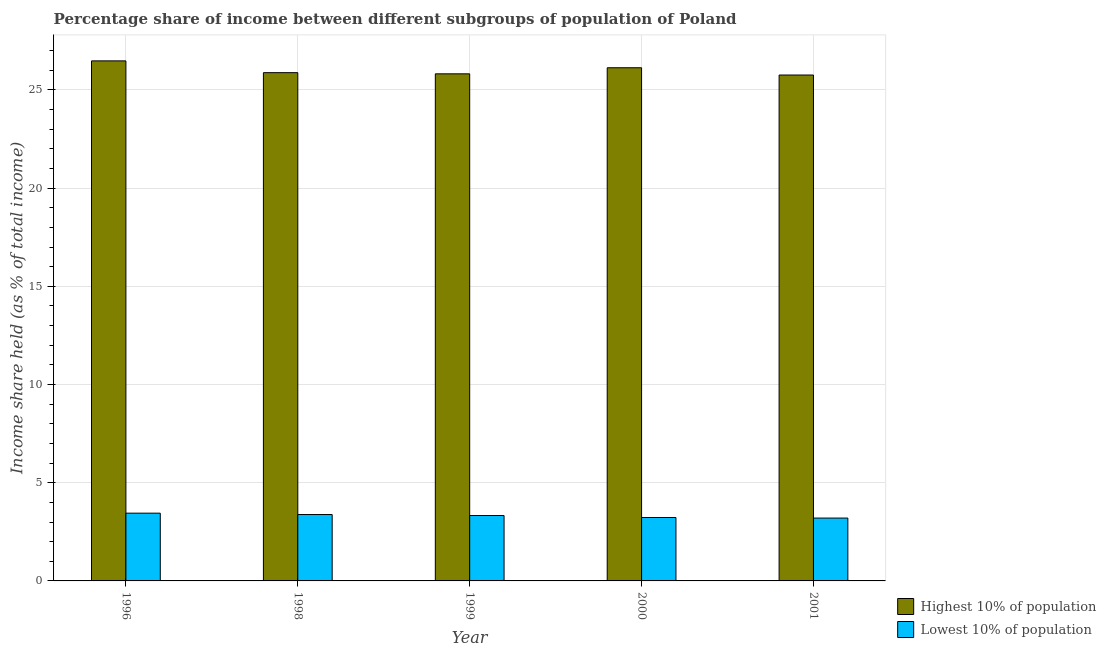How many different coloured bars are there?
Keep it short and to the point. 2. Are the number of bars per tick equal to the number of legend labels?
Your answer should be compact. Yes. How many bars are there on the 4th tick from the left?
Provide a succinct answer. 2. How many bars are there on the 1st tick from the right?
Your answer should be very brief. 2. What is the label of the 5th group of bars from the left?
Offer a very short reply. 2001. What is the income share held by lowest 10% of the population in 1999?
Make the answer very short. 3.33. Across all years, what is the maximum income share held by highest 10% of the population?
Keep it short and to the point. 26.48. In which year was the income share held by highest 10% of the population maximum?
Your answer should be compact. 1996. What is the total income share held by highest 10% of the population in the graph?
Keep it short and to the point. 130.07. What is the difference between the income share held by highest 10% of the population in 1998 and that in 1999?
Ensure brevity in your answer.  0.06. What is the difference between the income share held by highest 10% of the population in 1998 and the income share held by lowest 10% of the population in 1999?
Ensure brevity in your answer.  0.06. What is the average income share held by lowest 10% of the population per year?
Provide a short and direct response. 3.32. In the year 1996, what is the difference between the income share held by lowest 10% of the population and income share held by highest 10% of the population?
Your response must be concise. 0. In how many years, is the income share held by highest 10% of the population greater than 4 %?
Your response must be concise. 5. What is the ratio of the income share held by highest 10% of the population in 1996 to that in 2001?
Make the answer very short. 1.03. Is the difference between the income share held by lowest 10% of the population in 1996 and 2001 greater than the difference between the income share held by highest 10% of the population in 1996 and 2001?
Offer a terse response. No. What is the difference between the highest and the second highest income share held by lowest 10% of the population?
Offer a very short reply. 0.07. Is the sum of the income share held by highest 10% of the population in 1996 and 1999 greater than the maximum income share held by lowest 10% of the population across all years?
Your response must be concise. Yes. What does the 1st bar from the left in 2000 represents?
Your answer should be compact. Highest 10% of population. What does the 2nd bar from the right in 1998 represents?
Provide a succinct answer. Highest 10% of population. Are all the bars in the graph horizontal?
Ensure brevity in your answer.  No. How many years are there in the graph?
Ensure brevity in your answer.  5. What is the difference between two consecutive major ticks on the Y-axis?
Ensure brevity in your answer.  5. Are the values on the major ticks of Y-axis written in scientific E-notation?
Offer a very short reply. No. Where does the legend appear in the graph?
Give a very brief answer. Bottom right. What is the title of the graph?
Make the answer very short. Percentage share of income between different subgroups of population of Poland. Does "Taxes on exports" appear as one of the legend labels in the graph?
Give a very brief answer. No. What is the label or title of the X-axis?
Offer a very short reply. Year. What is the label or title of the Y-axis?
Your answer should be very brief. Income share held (as % of total income). What is the Income share held (as % of total income) in Highest 10% of population in 1996?
Your response must be concise. 26.48. What is the Income share held (as % of total income) of Lowest 10% of population in 1996?
Offer a very short reply. 3.45. What is the Income share held (as % of total income) of Highest 10% of population in 1998?
Offer a very short reply. 25.88. What is the Income share held (as % of total income) of Lowest 10% of population in 1998?
Your answer should be very brief. 3.38. What is the Income share held (as % of total income) of Highest 10% of population in 1999?
Offer a very short reply. 25.82. What is the Income share held (as % of total income) of Lowest 10% of population in 1999?
Your response must be concise. 3.33. What is the Income share held (as % of total income) in Highest 10% of population in 2000?
Make the answer very short. 26.13. What is the Income share held (as % of total income) in Lowest 10% of population in 2000?
Your answer should be compact. 3.23. What is the Income share held (as % of total income) of Highest 10% of population in 2001?
Offer a very short reply. 25.76. What is the Income share held (as % of total income) in Lowest 10% of population in 2001?
Provide a short and direct response. 3.2. Across all years, what is the maximum Income share held (as % of total income) in Highest 10% of population?
Keep it short and to the point. 26.48. Across all years, what is the maximum Income share held (as % of total income) in Lowest 10% of population?
Give a very brief answer. 3.45. Across all years, what is the minimum Income share held (as % of total income) in Highest 10% of population?
Provide a succinct answer. 25.76. Across all years, what is the minimum Income share held (as % of total income) in Lowest 10% of population?
Make the answer very short. 3.2. What is the total Income share held (as % of total income) of Highest 10% of population in the graph?
Provide a short and direct response. 130.07. What is the total Income share held (as % of total income) of Lowest 10% of population in the graph?
Your answer should be very brief. 16.59. What is the difference between the Income share held (as % of total income) in Highest 10% of population in 1996 and that in 1998?
Provide a short and direct response. 0.6. What is the difference between the Income share held (as % of total income) in Lowest 10% of population in 1996 and that in 1998?
Give a very brief answer. 0.07. What is the difference between the Income share held (as % of total income) in Highest 10% of population in 1996 and that in 1999?
Offer a terse response. 0.66. What is the difference between the Income share held (as % of total income) in Lowest 10% of population in 1996 and that in 1999?
Provide a succinct answer. 0.12. What is the difference between the Income share held (as % of total income) of Lowest 10% of population in 1996 and that in 2000?
Ensure brevity in your answer.  0.22. What is the difference between the Income share held (as % of total income) of Highest 10% of population in 1996 and that in 2001?
Ensure brevity in your answer.  0.72. What is the difference between the Income share held (as % of total income) in Lowest 10% of population in 1996 and that in 2001?
Keep it short and to the point. 0.25. What is the difference between the Income share held (as % of total income) in Highest 10% of population in 1998 and that in 1999?
Ensure brevity in your answer.  0.06. What is the difference between the Income share held (as % of total income) in Highest 10% of population in 1998 and that in 2001?
Provide a succinct answer. 0.12. What is the difference between the Income share held (as % of total income) of Lowest 10% of population in 1998 and that in 2001?
Your answer should be compact. 0.18. What is the difference between the Income share held (as % of total income) of Highest 10% of population in 1999 and that in 2000?
Your response must be concise. -0.31. What is the difference between the Income share held (as % of total income) in Lowest 10% of population in 1999 and that in 2001?
Your response must be concise. 0.13. What is the difference between the Income share held (as % of total income) of Highest 10% of population in 2000 and that in 2001?
Make the answer very short. 0.37. What is the difference between the Income share held (as % of total income) in Highest 10% of population in 1996 and the Income share held (as % of total income) in Lowest 10% of population in 1998?
Keep it short and to the point. 23.1. What is the difference between the Income share held (as % of total income) in Highest 10% of population in 1996 and the Income share held (as % of total income) in Lowest 10% of population in 1999?
Give a very brief answer. 23.15. What is the difference between the Income share held (as % of total income) of Highest 10% of population in 1996 and the Income share held (as % of total income) of Lowest 10% of population in 2000?
Your answer should be compact. 23.25. What is the difference between the Income share held (as % of total income) of Highest 10% of population in 1996 and the Income share held (as % of total income) of Lowest 10% of population in 2001?
Provide a succinct answer. 23.28. What is the difference between the Income share held (as % of total income) in Highest 10% of population in 1998 and the Income share held (as % of total income) in Lowest 10% of population in 1999?
Make the answer very short. 22.55. What is the difference between the Income share held (as % of total income) of Highest 10% of population in 1998 and the Income share held (as % of total income) of Lowest 10% of population in 2000?
Offer a very short reply. 22.65. What is the difference between the Income share held (as % of total income) of Highest 10% of population in 1998 and the Income share held (as % of total income) of Lowest 10% of population in 2001?
Your answer should be compact. 22.68. What is the difference between the Income share held (as % of total income) in Highest 10% of population in 1999 and the Income share held (as % of total income) in Lowest 10% of population in 2000?
Provide a succinct answer. 22.59. What is the difference between the Income share held (as % of total income) in Highest 10% of population in 1999 and the Income share held (as % of total income) in Lowest 10% of population in 2001?
Your response must be concise. 22.62. What is the difference between the Income share held (as % of total income) of Highest 10% of population in 2000 and the Income share held (as % of total income) of Lowest 10% of population in 2001?
Your answer should be compact. 22.93. What is the average Income share held (as % of total income) in Highest 10% of population per year?
Your answer should be very brief. 26.01. What is the average Income share held (as % of total income) of Lowest 10% of population per year?
Make the answer very short. 3.32. In the year 1996, what is the difference between the Income share held (as % of total income) of Highest 10% of population and Income share held (as % of total income) of Lowest 10% of population?
Offer a very short reply. 23.03. In the year 1999, what is the difference between the Income share held (as % of total income) in Highest 10% of population and Income share held (as % of total income) in Lowest 10% of population?
Provide a succinct answer. 22.49. In the year 2000, what is the difference between the Income share held (as % of total income) in Highest 10% of population and Income share held (as % of total income) in Lowest 10% of population?
Offer a very short reply. 22.9. In the year 2001, what is the difference between the Income share held (as % of total income) in Highest 10% of population and Income share held (as % of total income) in Lowest 10% of population?
Your answer should be very brief. 22.56. What is the ratio of the Income share held (as % of total income) in Highest 10% of population in 1996 to that in 1998?
Offer a terse response. 1.02. What is the ratio of the Income share held (as % of total income) of Lowest 10% of population in 1996 to that in 1998?
Your response must be concise. 1.02. What is the ratio of the Income share held (as % of total income) of Highest 10% of population in 1996 to that in 1999?
Ensure brevity in your answer.  1.03. What is the ratio of the Income share held (as % of total income) of Lowest 10% of population in 1996 to that in 1999?
Your response must be concise. 1.04. What is the ratio of the Income share held (as % of total income) of Highest 10% of population in 1996 to that in 2000?
Your response must be concise. 1.01. What is the ratio of the Income share held (as % of total income) in Lowest 10% of population in 1996 to that in 2000?
Your response must be concise. 1.07. What is the ratio of the Income share held (as % of total income) of Highest 10% of population in 1996 to that in 2001?
Provide a succinct answer. 1.03. What is the ratio of the Income share held (as % of total income) in Lowest 10% of population in 1996 to that in 2001?
Keep it short and to the point. 1.08. What is the ratio of the Income share held (as % of total income) of Highest 10% of population in 1998 to that in 1999?
Your answer should be compact. 1. What is the ratio of the Income share held (as % of total income) in Lowest 10% of population in 1998 to that in 2000?
Ensure brevity in your answer.  1.05. What is the ratio of the Income share held (as % of total income) in Lowest 10% of population in 1998 to that in 2001?
Your response must be concise. 1.06. What is the ratio of the Income share held (as % of total income) of Highest 10% of population in 1999 to that in 2000?
Your response must be concise. 0.99. What is the ratio of the Income share held (as % of total income) in Lowest 10% of population in 1999 to that in 2000?
Your answer should be very brief. 1.03. What is the ratio of the Income share held (as % of total income) of Highest 10% of population in 1999 to that in 2001?
Provide a succinct answer. 1. What is the ratio of the Income share held (as % of total income) of Lowest 10% of population in 1999 to that in 2001?
Offer a terse response. 1.04. What is the ratio of the Income share held (as % of total income) in Highest 10% of population in 2000 to that in 2001?
Your response must be concise. 1.01. What is the ratio of the Income share held (as % of total income) of Lowest 10% of population in 2000 to that in 2001?
Keep it short and to the point. 1.01. What is the difference between the highest and the second highest Income share held (as % of total income) of Highest 10% of population?
Your answer should be compact. 0.35. What is the difference between the highest and the second highest Income share held (as % of total income) in Lowest 10% of population?
Provide a succinct answer. 0.07. What is the difference between the highest and the lowest Income share held (as % of total income) of Highest 10% of population?
Provide a short and direct response. 0.72. What is the difference between the highest and the lowest Income share held (as % of total income) in Lowest 10% of population?
Your response must be concise. 0.25. 